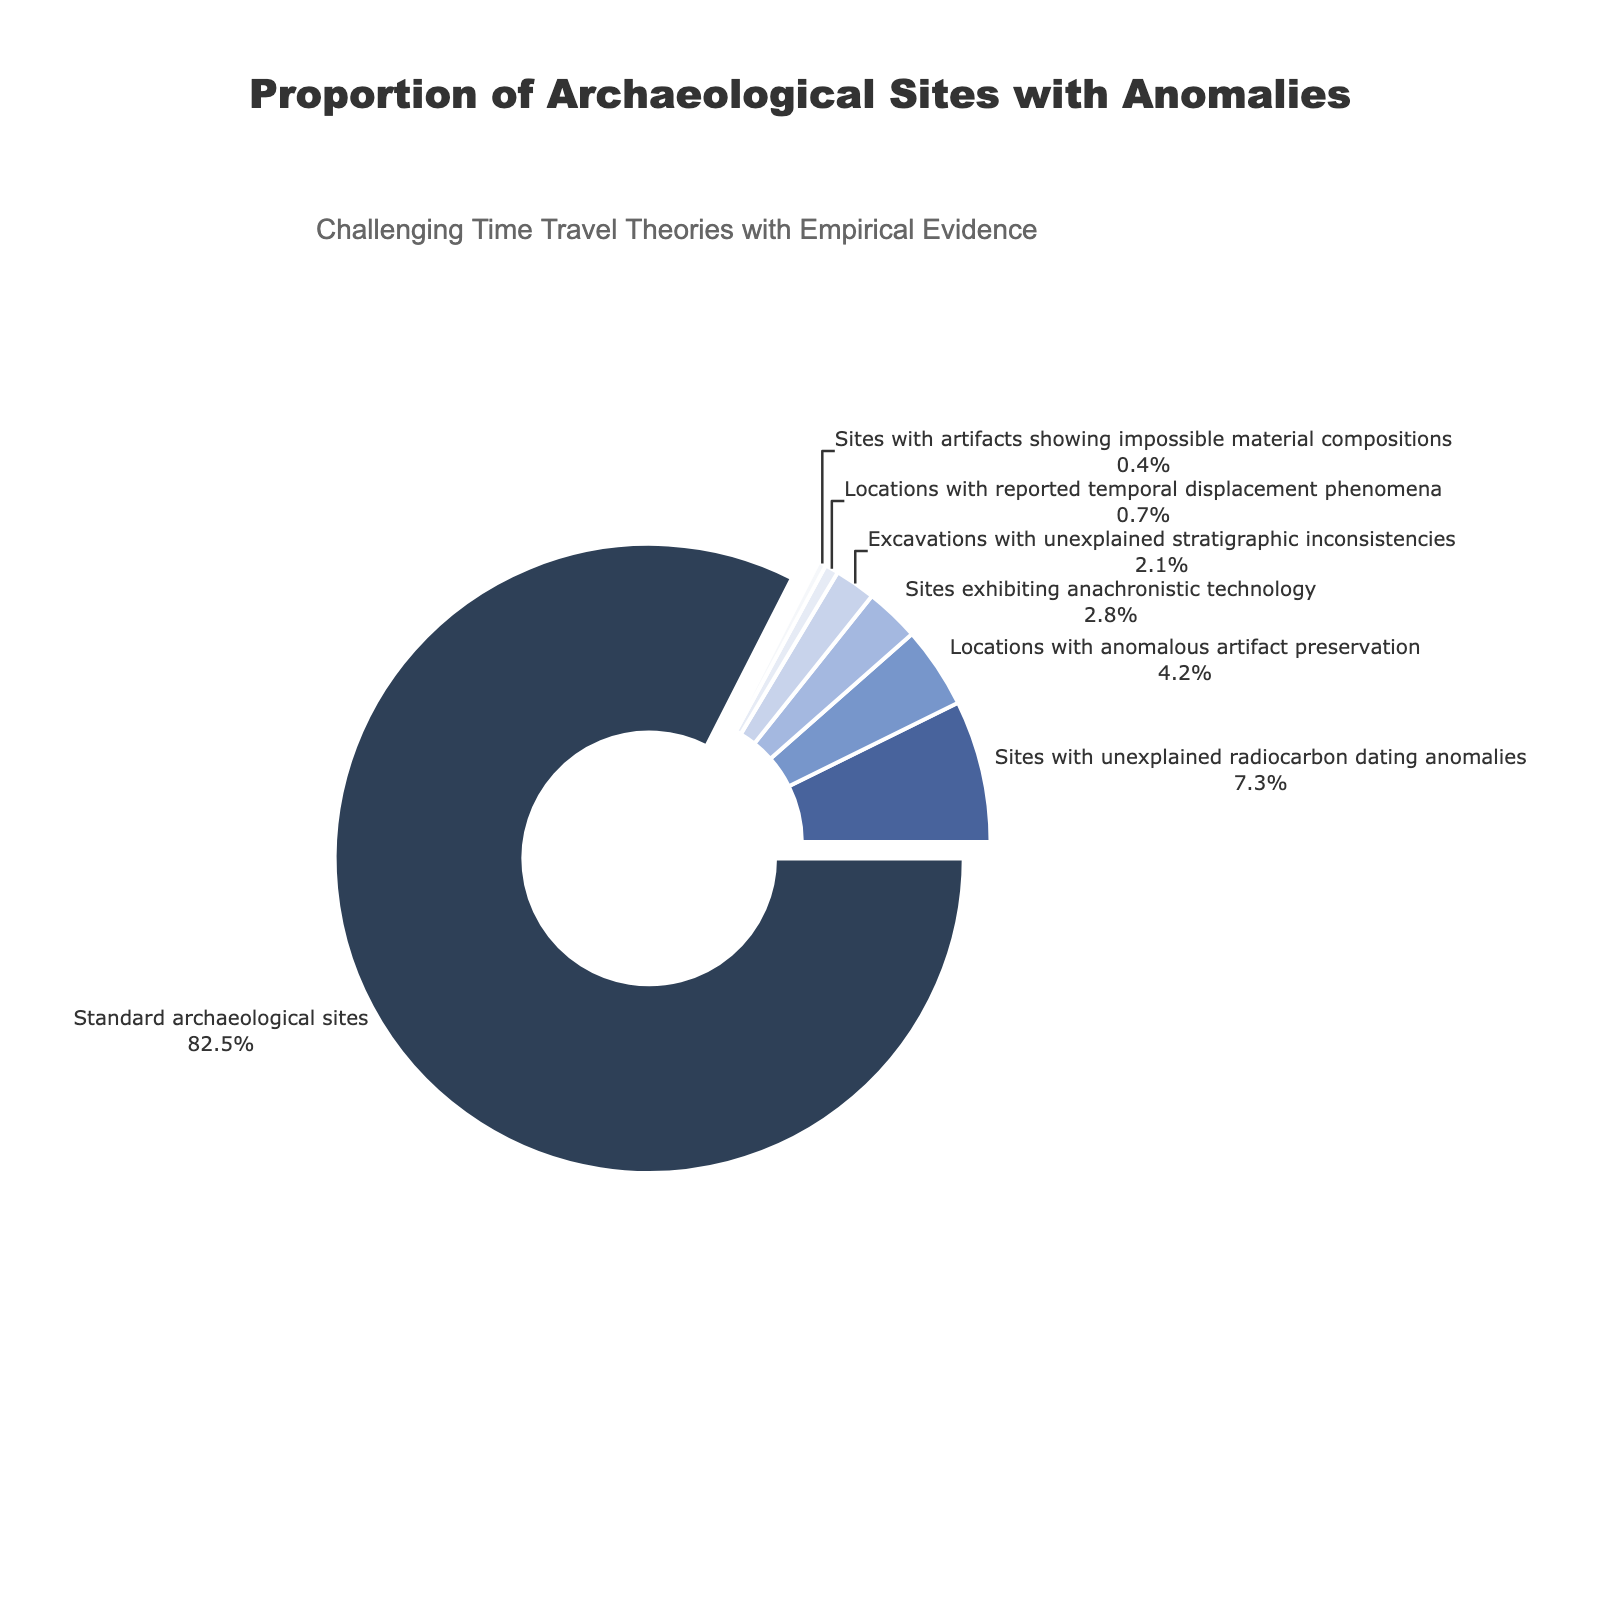How many percentage points more do standard archaeological sites have compared to sites with unexplained radiocarbon dating anomalies? Standard archaeological sites have 82.5% and sites with unexplained radiocarbon dating anomalies have 7.3%. The difference is calculated as 82.5 - 7.3 = 75.2 percentage points.
Answer: 75.2 What is the combined percentage of sites with unexplained stratigraphic inconsistencies and locations with reported temporal displacement phenomena? The percentage of sites with unexplained stratigraphic inconsistencies is 2.1% and for locations with reported temporal displacement phenomena it is 0.7%. The combined percentage is 2.1 + 0.7 = 2.8%.
Answer: 2.8% Which category has the second smallest representation? The categories with their percentages are: Standard archaeological sites (82.5%), Sites with unexplained radiocarbon dating anomalies (7.3%), Locations with anomalous artifact preservation (4.2%), Sites exhibiting anachronistic technology (2.8%), Excavations with unexplained stratigraphic inconsistencies (2.1%), Locations with reported temporal displacement phenomena (0.7%), Sites with artifacts showing impossible material compositions (0.4%). The second smallest percentage is 0.7%, corresponding to Locations with reported temporal displacement phenomena.
Answer: Locations with reported temporal displacement phenomena How much larger is the proportion of standard archaeological sites compared to the proportion of sites exhibiting anachronistic technology? Standard archaeological sites are 82.5% and sites exhibiting anachronistic technology are 2.8%. The proportion is calculated as 82.5 / 2.8 ≈ 29.46 times larger.
Answer: ~29.46 times If sites with artifacts showing impossible material compositions doubled in percentage, what would the new total percentage be for this category? The current percentage for sites with artifacts showing impossible material compositions is 0.4%. If this doubles, it would be 0.4 * 2 = 0.8%.
Answer: 0.8% Which category is represented by the color corresponding to 'E6EBF5'? The color 'F5F7FA' in the code appears to be the lightest. According to the categories and the percentages given to the colors, this color represents Sites with artifacts showing impossible material compositions (0.4%).
Answer: Sites with artifacts showing impossible material compositions What is the difference in percentage between the category with the highest proportion and the category with the lowest proportion? The category with the highest proportion is Standard archaeological sites (82.5%) and the category with the lowest proportion is Sites with artifacts showing impossible material compositions (0.4%). The difference is 82.5 - 0.4 = 82.1%.
Answer: 82.1% Which three categories collectively represent less than 10% of the total? The percentages for the categories are: Sites exhibiting anachronistic technology (2.8%), Excavations with unexplained stratigraphic inconsistencies (2.1%), Locations with reported temporal displacement phenomena (0.7%), Sites with artifacts showing impossible material compositions (0.4%). Summing the three smallest, we get 2.1 + 0.7 + 0.4 = 3.2%, which is less than 10%.
Answer: Excavations with unexplained stratigraphic inconsistencies, Locations with reported temporal displacement phenomena, Sites with artifacts showing impossible material compositions 